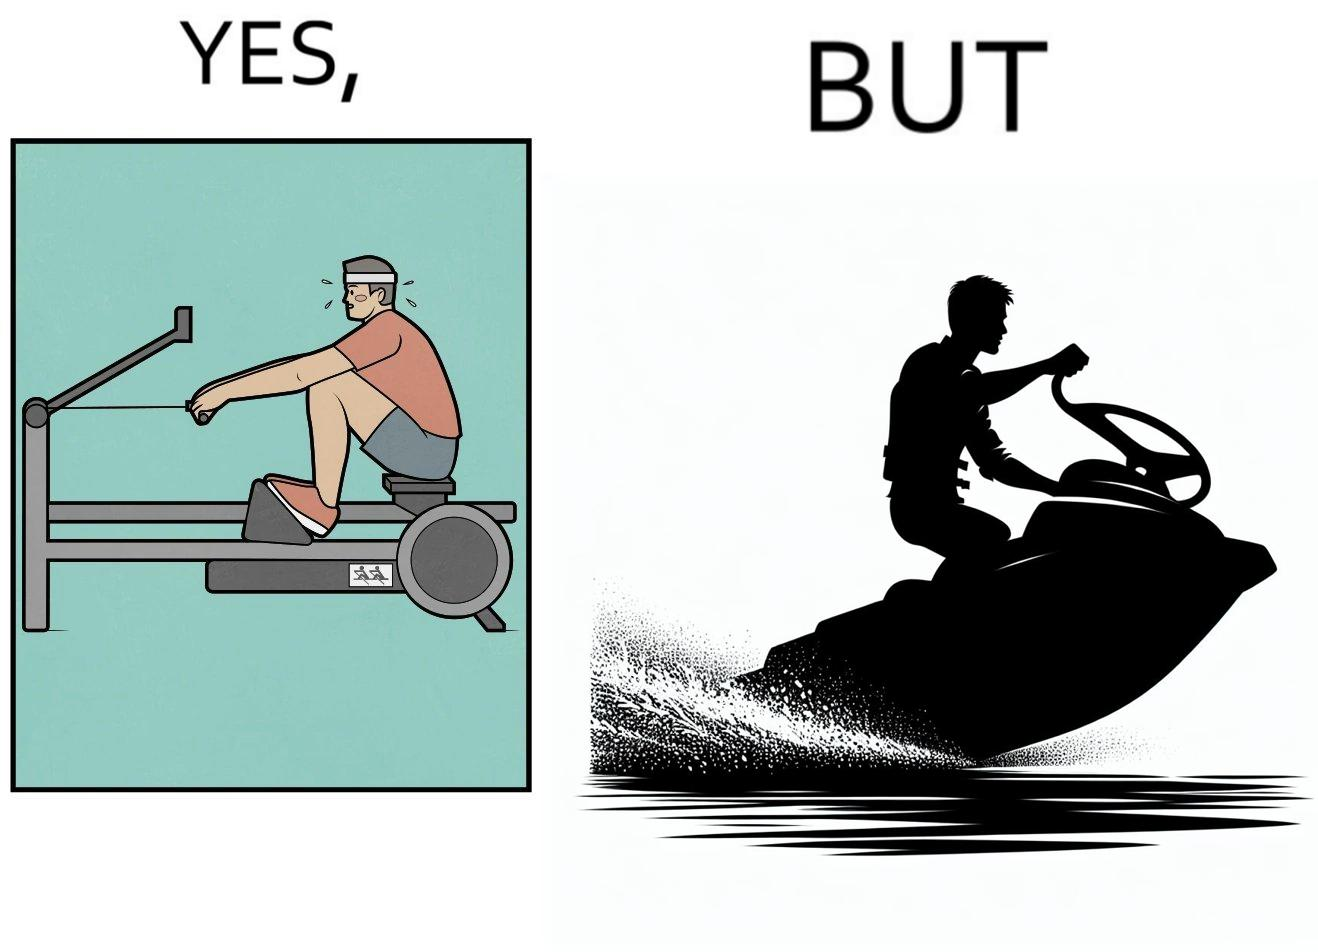What is shown in the left half versus the right half of this image? In the left part of the image: a person doing rowing exercise in gym In the right part of the image: a person riding a motorboat 